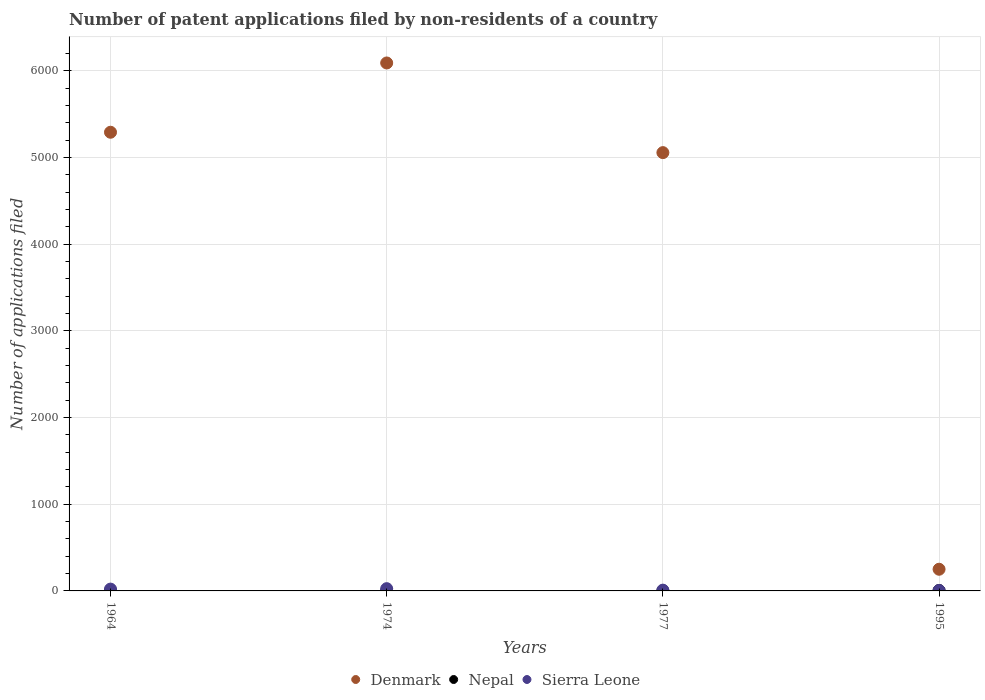Across all years, what is the maximum number of applications filed in Denmark?
Your response must be concise. 6089. Across all years, what is the minimum number of applications filed in Denmark?
Offer a terse response. 250. In which year was the number of applications filed in Nepal maximum?
Make the answer very short. 1964. In which year was the number of applications filed in Nepal minimum?
Provide a short and direct response. 1977. What is the total number of applications filed in Sierra Leone in the graph?
Provide a short and direct response. 61. What is the difference between the number of applications filed in Nepal in 1964 and that in 1995?
Offer a terse response. 0. What is the difference between the number of applications filed in Denmark in 1977 and the number of applications filed in Nepal in 1964?
Offer a terse response. 5050. What is the average number of applications filed in Denmark per year?
Keep it short and to the point. 4171. What is the ratio of the number of applications filed in Denmark in 1964 to that in 1974?
Give a very brief answer. 0.87. What is the difference between the highest and the second highest number of applications filed in Denmark?
Provide a short and direct response. 799. What is the difference between the highest and the lowest number of applications filed in Denmark?
Provide a succinct answer. 5839. In how many years, is the number of applications filed in Denmark greater than the average number of applications filed in Denmark taken over all years?
Make the answer very short. 3. Is it the case that in every year, the sum of the number of applications filed in Sierra Leone and number of applications filed in Nepal  is greater than the number of applications filed in Denmark?
Offer a very short reply. No. Is the number of applications filed in Sierra Leone strictly greater than the number of applications filed in Nepal over the years?
Offer a very short reply. No. Is the number of applications filed in Sierra Leone strictly less than the number of applications filed in Denmark over the years?
Your answer should be compact. Yes. How many years are there in the graph?
Your response must be concise. 4. Are the values on the major ticks of Y-axis written in scientific E-notation?
Ensure brevity in your answer.  No. Does the graph contain any zero values?
Give a very brief answer. No. What is the title of the graph?
Give a very brief answer. Number of patent applications filed by non-residents of a country. Does "Papua New Guinea" appear as one of the legend labels in the graph?
Your answer should be very brief. No. What is the label or title of the Y-axis?
Make the answer very short. Number of applications filed. What is the Number of applications filed of Denmark in 1964?
Provide a short and direct response. 5290. What is the Number of applications filed in Nepal in 1964?
Provide a short and direct response. 5. What is the Number of applications filed in Denmark in 1974?
Provide a short and direct response. 6089. What is the Number of applications filed of Nepal in 1974?
Make the answer very short. 2. What is the Number of applications filed in Denmark in 1977?
Provide a short and direct response. 5055. What is the Number of applications filed in Denmark in 1995?
Your answer should be compact. 250. What is the Number of applications filed in Nepal in 1995?
Keep it short and to the point. 5. What is the Number of applications filed in Sierra Leone in 1995?
Make the answer very short. 5. Across all years, what is the maximum Number of applications filed in Denmark?
Make the answer very short. 6089. Across all years, what is the minimum Number of applications filed of Denmark?
Offer a terse response. 250. Across all years, what is the minimum Number of applications filed of Nepal?
Ensure brevity in your answer.  1. Across all years, what is the minimum Number of applications filed of Sierra Leone?
Make the answer very short. 5. What is the total Number of applications filed of Denmark in the graph?
Offer a very short reply. 1.67e+04. What is the total Number of applications filed in Nepal in the graph?
Provide a succinct answer. 13. What is the difference between the Number of applications filed in Denmark in 1964 and that in 1974?
Your response must be concise. -799. What is the difference between the Number of applications filed in Denmark in 1964 and that in 1977?
Give a very brief answer. 235. What is the difference between the Number of applications filed of Nepal in 1964 and that in 1977?
Ensure brevity in your answer.  4. What is the difference between the Number of applications filed in Denmark in 1964 and that in 1995?
Your answer should be very brief. 5040. What is the difference between the Number of applications filed of Nepal in 1964 and that in 1995?
Ensure brevity in your answer.  0. What is the difference between the Number of applications filed of Denmark in 1974 and that in 1977?
Your response must be concise. 1034. What is the difference between the Number of applications filed of Sierra Leone in 1974 and that in 1977?
Ensure brevity in your answer.  17. What is the difference between the Number of applications filed of Denmark in 1974 and that in 1995?
Ensure brevity in your answer.  5839. What is the difference between the Number of applications filed in Sierra Leone in 1974 and that in 1995?
Ensure brevity in your answer.  21. What is the difference between the Number of applications filed of Denmark in 1977 and that in 1995?
Ensure brevity in your answer.  4805. What is the difference between the Number of applications filed in Denmark in 1964 and the Number of applications filed in Nepal in 1974?
Offer a terse response. 5288. What is the difference between the Number of applications filed of Denmark in 1964 and the Number of applications filed of Sierra Leone in 1974?
Keep it short and to the point. 5264. What is the difference between the Number of applications filed of Denmark in 1964 and the Number of applications filed of Nepal in 1977?
Offer a terse response. 5289. What is the difference between the Number of applications filed in Denmark in 1964 and the Number of applications filed in Sierra Leone in 1977?
Make the answer very short. 5281. What is the difference between the Number of applications filed of Nepal in 1964 and the Number of applications filed of Sierra Leone in 1977?
Offer a very short reply. -4. What is the difference between the Number of applications filed of Denmark in 1964 and the Number of applications filed of Nepal in 1995?
Offer a terse response. 5285. What is the difference between the Number of applications filed of Denmark in 1964 and the Number of applications filed of Sierra Leone in 1995?
Your answer should be compact. 5285. What is the difference between the Number of applications filed of Denmark in 1974 and the Number of applications filed of Nepal in 1977?
Keep it short and to the point. 6088. What is the difference between the Number of applications filed of Denmark in 1974 and the Number of applications filed of Sierra Leone in 1977?
Give a very brief answer. 6080. What is the difference between the Number of applications filed of Denmark in 1974 and the Number of applications filed of Nepal in 1995?
Ensure brevity in your answer.  6084. What is the difference between the Number of applications filed in Denmark in 1974 and the Number of applications filed in Sierra Leone in 1995?
Provide a succinct answer. 6084. What is the difference between the Number of applications filed of Denmark in 1977 and the Number of applications filed of Nepal in 1995?
Your answer should be compact. 5050. What is the difference between the Number of applications filed in Denmark in 1977 and the Number of applications filed in Sierra Leone in 1995?
Provide a short and direct response. 5050. What is the average Number of applications filed in Denmark per year?
Offer a very short reply. 4171. What is the average Number of applications filed in Nepal per year?
Your response must be concise. 3.25. What is the average Number of applications filed in Sierra Leone per year?
Your answer should be compact. 15.25. In the year 1964, what is the difference between the Number of applications filed in Denmark and Number of applications filed in Nepal?
Provide a succinct answer. 5285. In the year 1964, what is the difference between the Number of applications filed in Denmark and Number of applications filed in Sierra Leone?
Your answer should be compact. 5269. In the year 1964, what is the difference between the Number of applications filed of Nepal and Number of applications filed of Sierra Leone?
Provide a short and direct response. -16. In the year 1974, what is the difference between the Number of applications filed of Denmark and Number of applications filed of Nepal?
Ensure brevity in your answer.  6087. In the year 1974, what is the difference between the Number of applications filed in Denmark and Number of applications filed in Sierra Leone?
Your answer should be compact. 6063. In the year 1974, what is the difference between the Number of applications filed in Nepal and Number of applications filed in Sierra Leone?
Keep it short and to the point. -24. In the year 1977, what is the difference between the Number of applications filed in Denmark and Number of applications filed in Nepal?
Your answer should be very brief. 5054. In the year 1977, what is the difference between the Number of applications filed of Denmark and Number of applications filed of Sierra Leone?
Offer a terse response. 5046. In the year 1977, what is the difference between the Number of applications filed of Nepal and Number of applications filed of Sierra Leone?
Your answer should be very brief. -8. In the year 1995, what is the difference between the Number of applications filed of Denmark and Number of applications filed of Nepal?
Provide a succinct answer. 245. In the year 1995, what is the difference between the Number of applications filed in Denmark and Number of applications filed in Sierra Leone?
Your answer should be compact. 245. What is the ratio of the Number of applications filed in Denmark in 1964 to that in 1974?
Keep it short and to the point. 0.87. What is the ratio of the Number of applications filed of Nepal in 1964 to that in 1974?
Provide a succinct answer. 2.5. What is the ratio of the Number of applications filed of Sierra Leone in 1964 to that in 1974?
Ensure brevity in your answer.  0.81. What is the ratio of the Number of applications filed of Denmark in 1964 to that in 1977?
Make the answer very short. 1.05. What is the ratio of the Number of applications filed of Sierra Leone in 1964 to that in 1977?
Offer a very short reply. 2.33. What is the ratio of the Number of applications filed in Denmark in 1964 to that in 1995?
Keep it short and to the point. 21.16. What is the ratio of the Number of applications filed of Nepal in 1964 to that in 1995?
Provide a succinct answer. 1. What is the ratio of the Number of applications filed in Sierra Leone in 1964 to that in 1995?
Your response must be concise. 4.2. What is the ratio of the Number of applications filed in Denmark in 1974 to that in 1977?
Offer a terse response. 1.2. What is the ratio of the Number of applications filed of Sierra Leone in 1974 to that in 1977?
Offer a very short reply. 2.89. What is the ratio of the Number of applications filed in Denmark in 1974 to that in 1995?
Provide a short and direct response. 24.36. What is the ratio of the Number of applications filed in Denmark in 1977 to that in 1995?
Ensure brevity in your answer.  20.22. What is the difference between the highest and the second highest Number of applications filed of Denmark?
Make the answer very short. 799. What is the difference between the highest and the second highest Number of applications filed in Nepal?
Your answer should be very brief. 0. What is the difference between the highest and the lowest Number of applications filed of Denmark?
Give a very brief answer. 5839. What is the difference between the highest and the lowest Number of applications filed of Sierra Leone?
Ensure brevity in your answer.  21. 